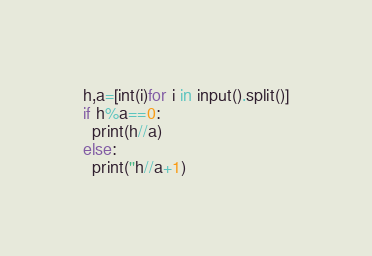Convert code to text. <code><loc_0><loc_0><loc_500><loc_500><_Python_>h,a=[int(i)for i in input().split()]
if h%a==0:
  print(h//a)
else:
  print(''h//a+1)</code> 